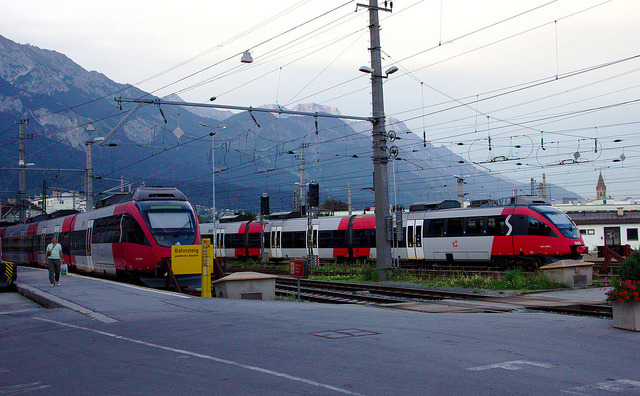How many people are walking in the photo? In the image, there is one individual who appears to be walking towards the foreground, adjacent to the train tracks. The person seems to be proceeding with a purpose, possibly towards a nearby destination. 